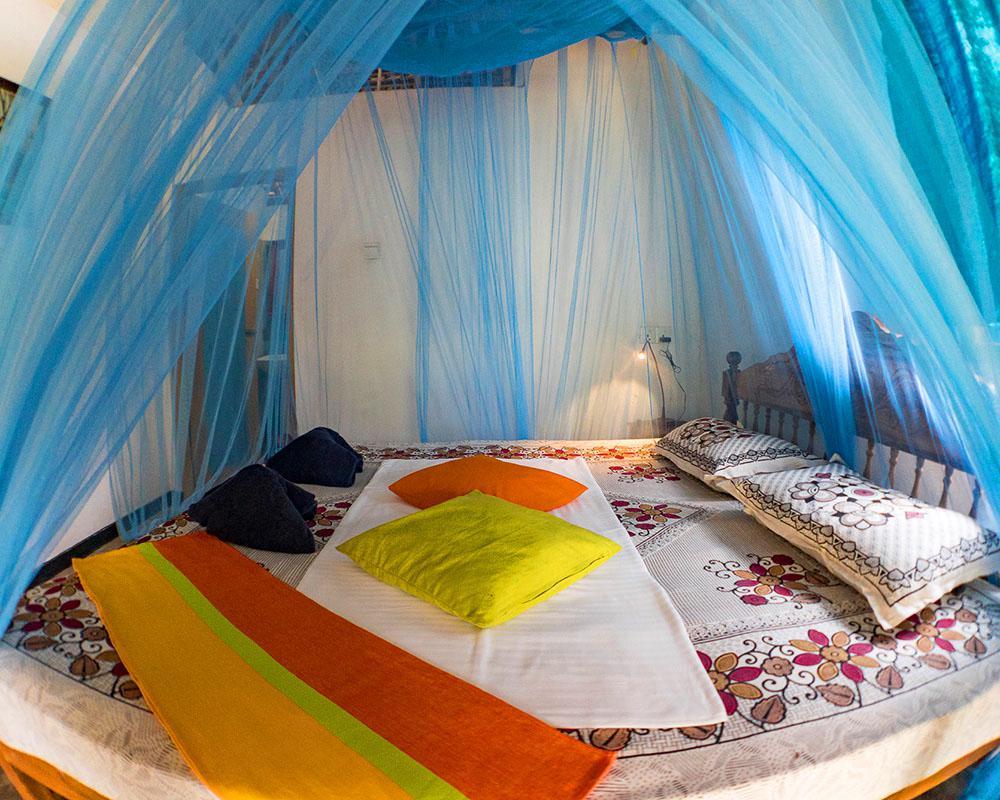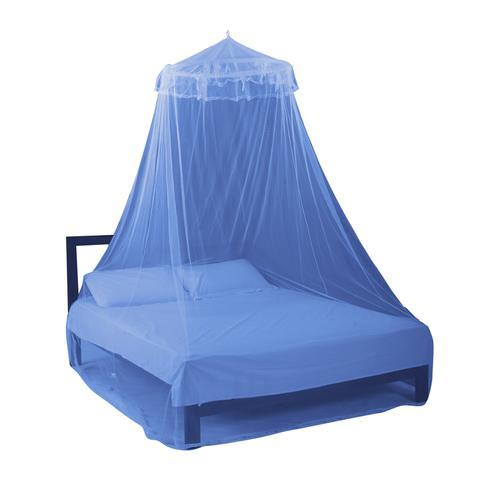The first image is the image on the left, the second image is the image on the right. Analyze the images presented: Is the assertion "Each image shows a bed with a dome-shaped canopy over its mattress like a tent, and at least one canopy has blue edges." valid? Answer yes or no. No. The first image is the image on the left, the second image is the image on the right. Considering the images on both sides, is "One bed netting is pink." valid? Answer yes or no. No. 